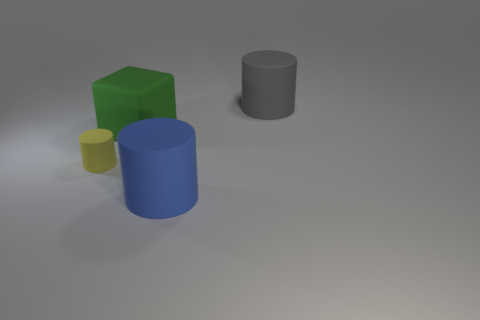Is the shape of the gray thing the same as the big green matte thing?
Give a very brief answer. No. How many other objects are the same shape as the gray thing?
Offer a terse response. 2. What is the color of the matte cylinder that is the same size as the gray rubber object?
Offer a terse response. Blue. Is the number of big green matte things that are behind the gray cylinder the same as the number of big yellow metallic cubes?
Offer a terse response. Yes. The rubber thing that is both in front of the green object and to the right of the small cylinder has what shape?
Your answer should be very brief. Cylinder. Is the gray matte cylinder the same size as the yellow matte thing?
Give a very brief answer. No. Are there any blue cylinders that have the same material as the big gray object?
Your answer should be compact. Yes. What number of rubber objects are both in front of the large green cube and on the right side of the tiny yellow thing?
Ensure brevity in your answer.  1. What is the size of the green cube that is made of the same material as the gray cylinder?
Offer a very short reply. Large. How many things are either gray rubber cylinders or big gray shiny cubes?
Offer a very short reply. 1. 